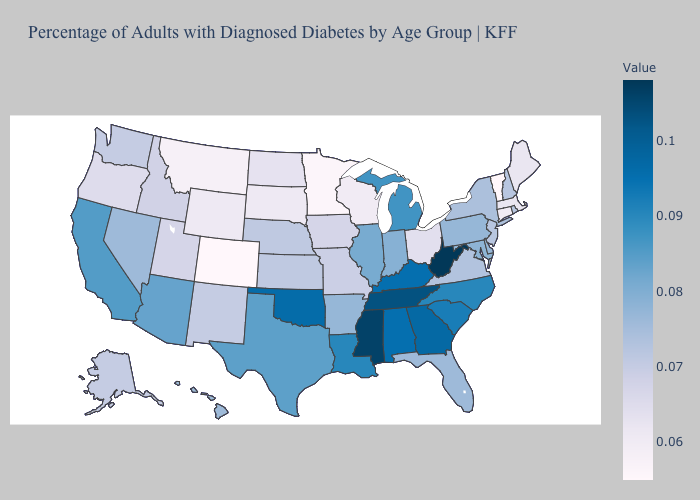Does Michigan have the highest value in the MidWest?
Concise answer only. Yes. Among the states that border West Virginia , does Pennsylvania have the lowest value?
Answer briefly. No. Does Pennsylvania have the highest value in the USA?
Concise answer only. No. Is the legend a continuous bar?
Concise answer only. Yes. 